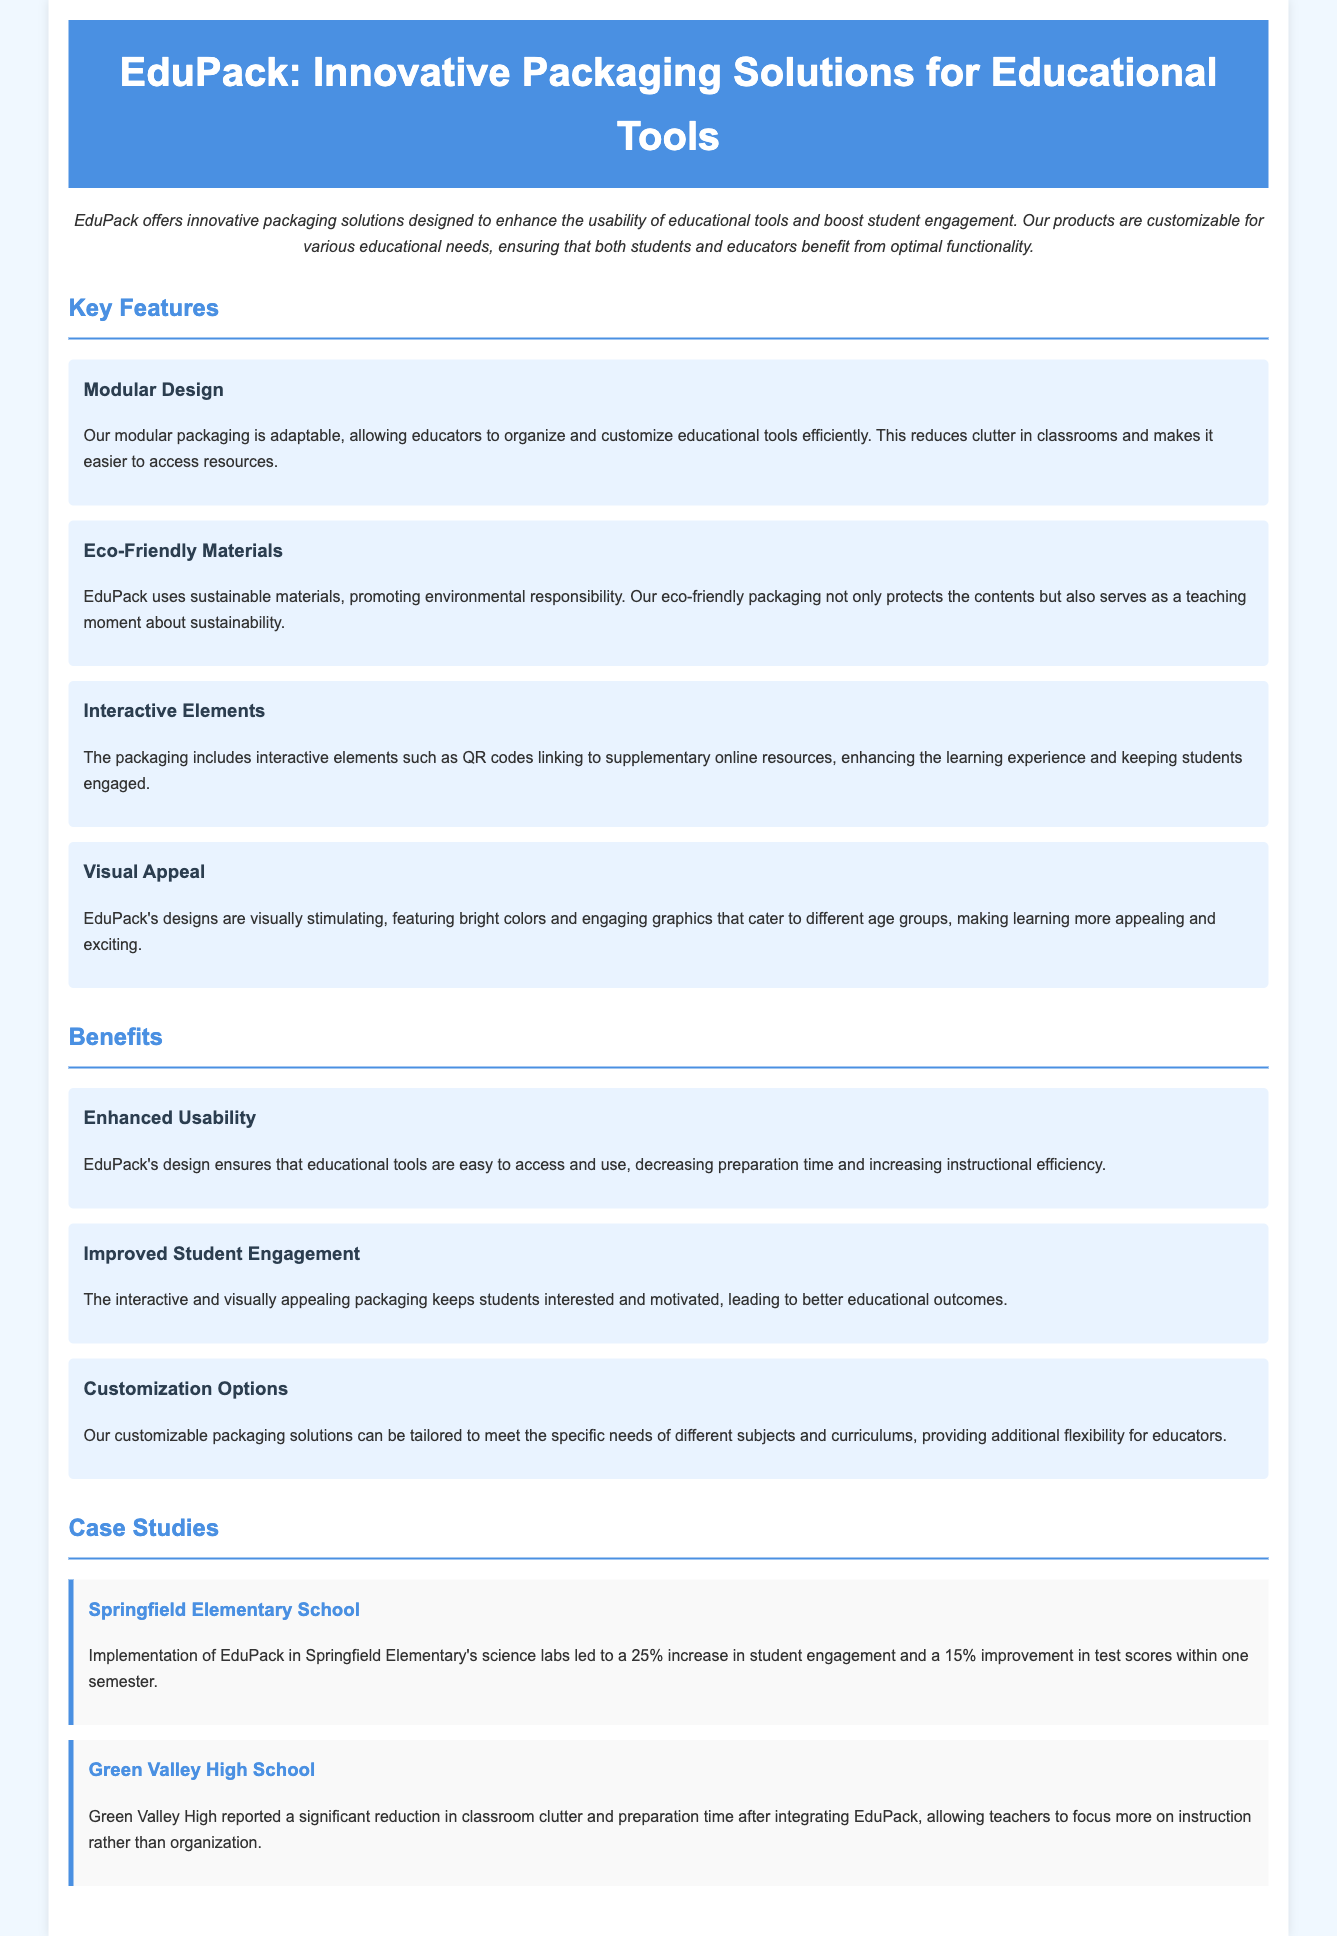What is the name of the product discussed? The product is titled "EduPack," which is mentioned in the header of the document.
Answer: EduPack What feature promotes environmental responsibility? The feature highlights the use of sustainable materials, as stated under "Eco-Friendly Materials."
Answer: Eco-Friendly Materials What percentage increase in student engagement was reported by Springfield Elementary School? The document cites a 25% increase in student engagement after implementing EduPack.
Answer: 25% What is the main benefit related to preparation time? The document states that EduPack enhances usability, which decreases preparation time.
Answer: Decreased preparation time What interactive elements are included in the packaging? The packaging includes QR codes linking to supplementary online resources, mentioned under "Interactive Elements."
Answer: QR codes What is the visual characteristic of EduPack’s design? The design is described as visually stimulating with bright colors and engaging graphics.
Answer: Visually stimulating How does EduPack affect instructional efficiency? The design ensures educational tools are easy to access and use, as described under "Enhanced Usability."
Answer: Increasing instructional efficiency What customization option is provided by EduPack? The customization options can be tailored to meet specific needs of different subjects and curriculums.
Answer: Tailored to subjects and curriculums 